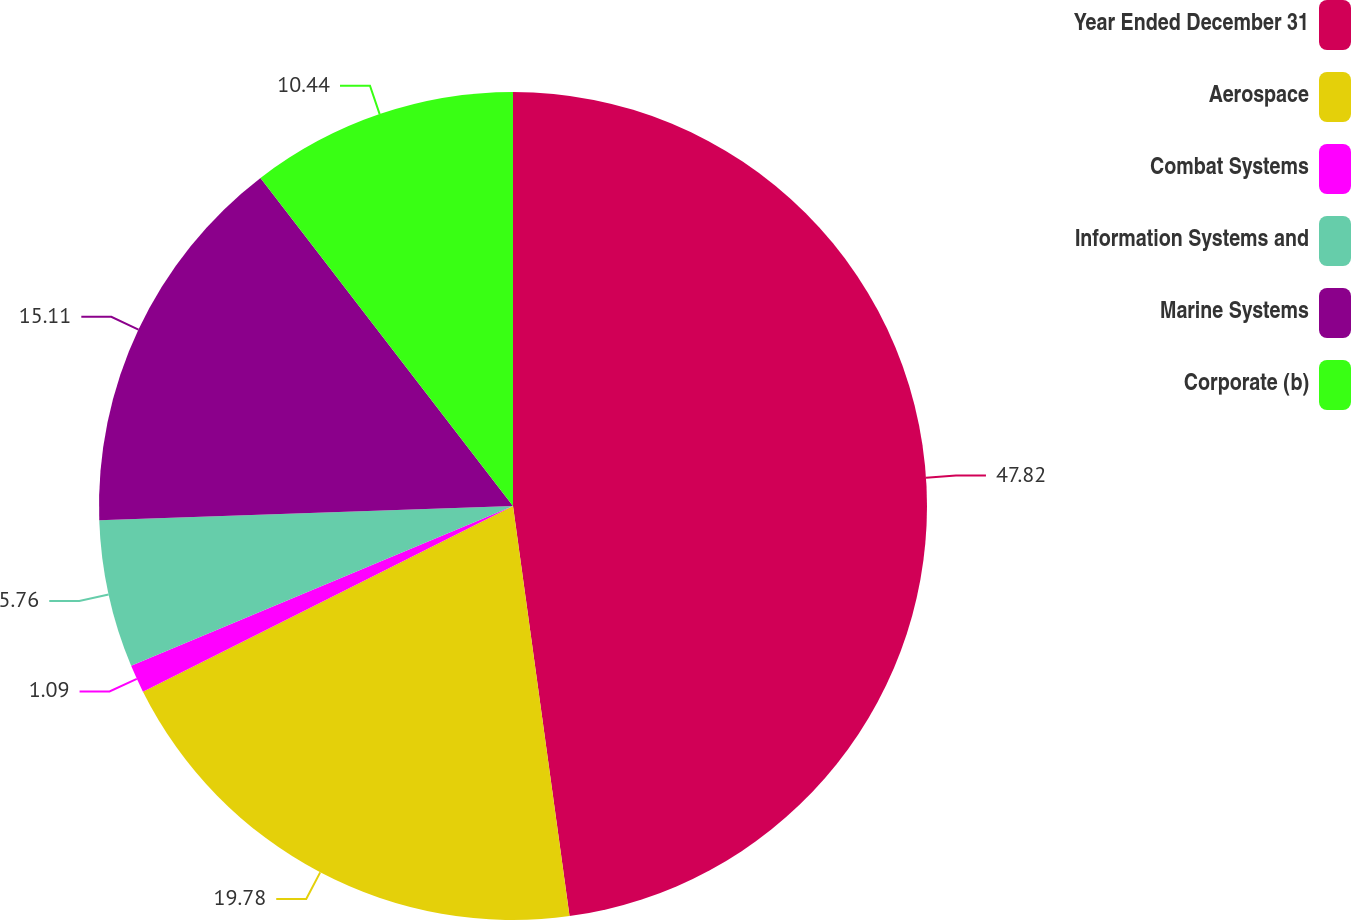Convert chart. <chart><loc_0><loc_0><loc_500><loc_500><pie_chart><fcel>Year Ended December 31<fcel>Aerospace<fcel>Combat Systems<fcel>Information Systems and<fcel>Marine Systems<fcel>Corporate (b)<nl><fcel>47.82%<fcel>19.78%<fcel>1.09%<fcel>5.76%<fcel>15.11%<fcel>10.44%<nl></chart> 